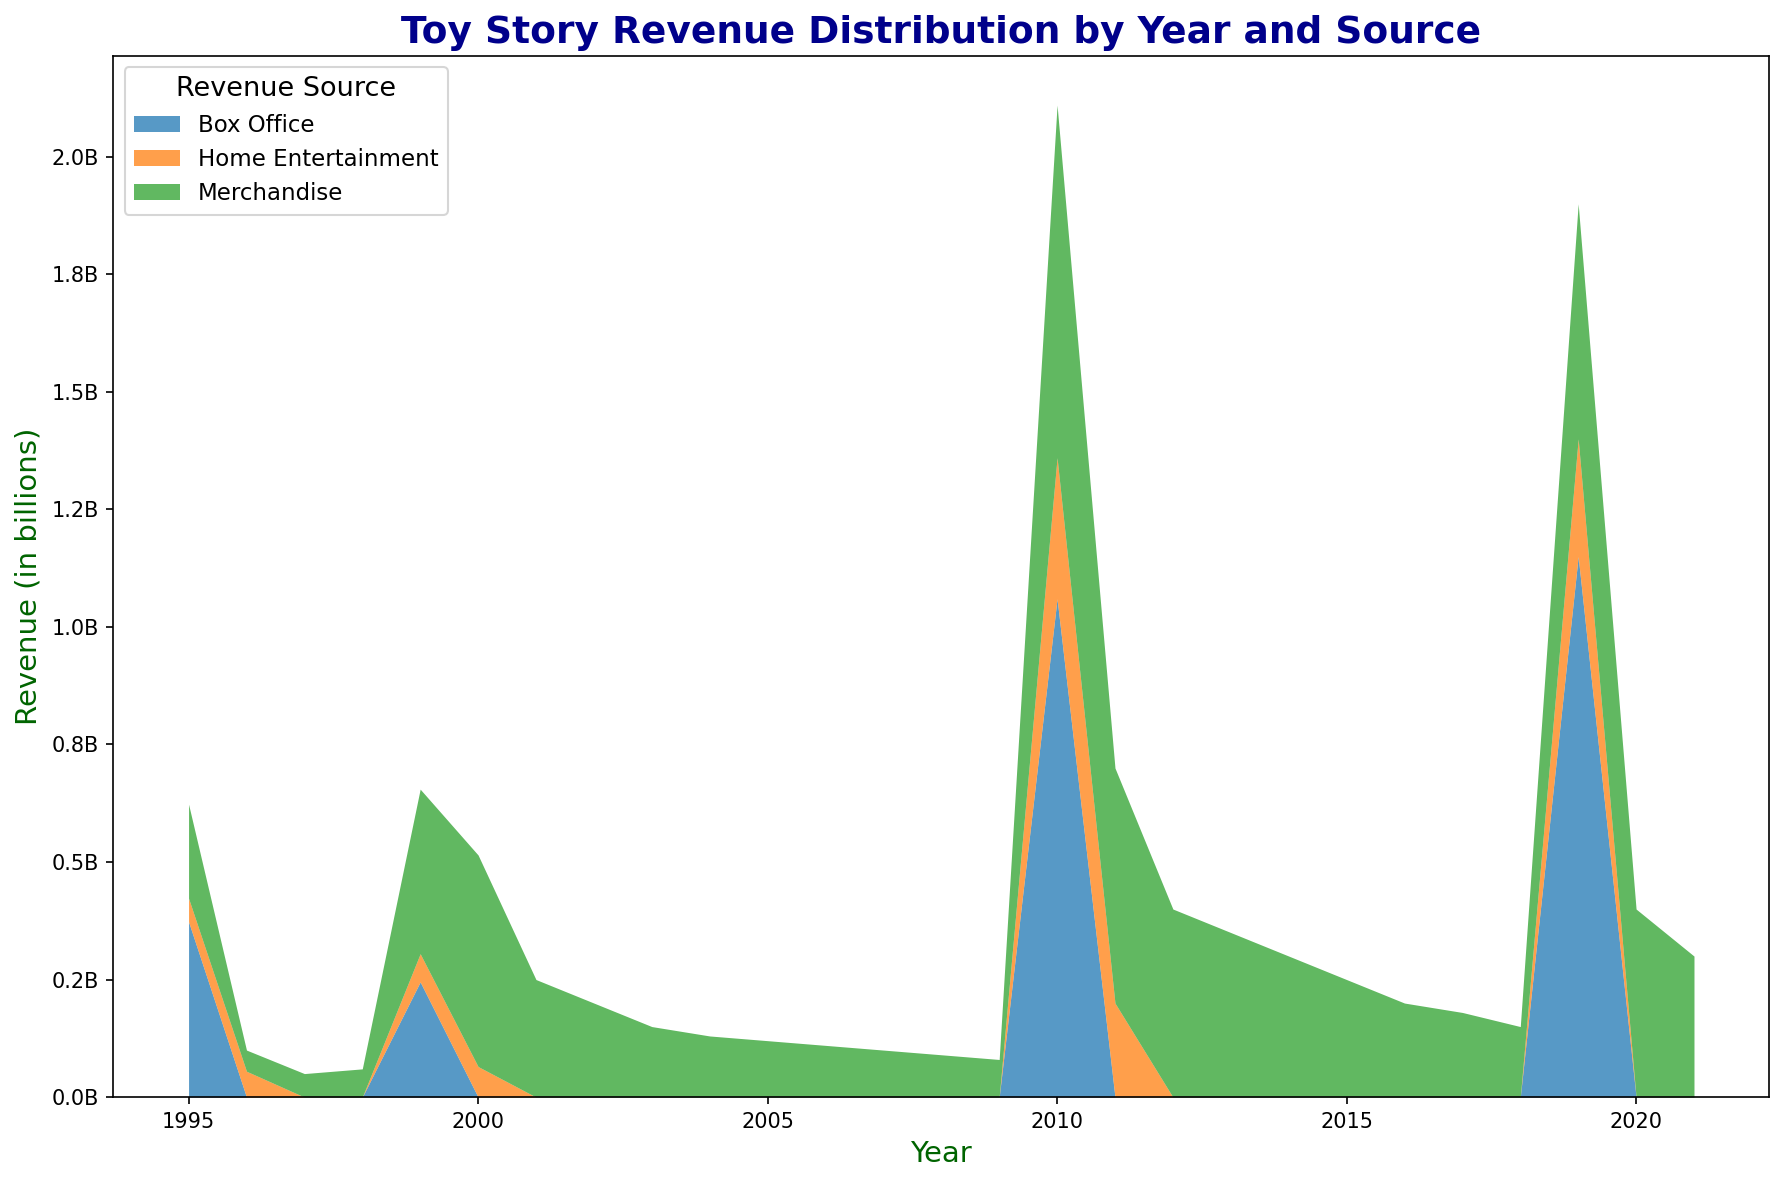What years did Toy Story movies generate box office revenue? By observing the x-axis for box office revenue areas, the years with noticeable contribution are 1995, 1999, 2010, and 2019. These are depicted by the distinct portions in each year for box office earnings.
Answer: 1995, 1999, 2010, 2019 Which source of revenue consistently generated the most income throughout the years? By assessing the stacked area chart, it's clear that merchandise revenue consistently occupies the largest area across most years. This indicates that merchandise has been the most substantial source of revenue over time.
Answer: Merchandise In which year did merchandise revenue peak? We can determine that merchandise revenue peaked by identifying the year with the highest area width for merchandise. The largest segment occurs in 2010, indicating the peak for merchandise revenue.
Answer: 2010 Compare the box office revenue between 2010 and 2019. Which year had higher revenue and by how much? Examining the areas corresponding to box office revenue for both 2010 and 2019 shows that 2019 had a higher revenue. Calculating the difference, we see 2019 had $1,150,000,000 whereas 2010 had $1,060,000,000. The difference is $90,000,000.
Answer: 2019 by $90,000,000 What is the total revenue generated in 2010 from all sources? Adding the revenues from box office ($1,060,000,000), merchandise ($750,000,000), and home entertainment ($300,000,000) for 2010 gives the total revenue: $1,060,000,000 + $750,000,000 + $300,000,000 = $2,110,000,000.
Answer: $2,110,000,000 Which source had the most variable revenue over the years, and how can you tell? By looking at the vertical height variations for each source, box office and home entertainment show significant fluctuations, but merchandise exhibits the largest changes over multiple years, indicating it is the most variable.
Answer: Merchandise How does the 2011 home entertainment revenue compare to that in 2010? Observing the heights of the home entertainment areas for 2010 and 2011, 2010 shows $300,000,000 whereas 2011 shows $200,000,000. Therefore, 2010 generated $100,000,000 more from home entertainment than 2011.
Answer: 2010 had $100,000,000 more What is the average merchandise revenue from 2017 to 2021? Summing the merchandise revenue values from 2017 to 2021 ($180,000,000 + $150,000,000 + $500,000,000 + $400,000,000 + $300,000,000) gives $1,530,000,000. Dividing by 5 (number of years) gives the average: $1,530,000,000 / 5 = $306,000,000.
Answer: $306,000,000 In which year did home entertainment revenue first exceed $200,000,000? Reviewing the home entertainment areas, the first instance where it exceeds $200,000,000 is in 2010, where it reached $300,000,000.
Answer: 2010 Compare the combined revenues of merchandise in 1995 and 1996 against 1999. Which is greater? Summing merchandise revenues for 1995 ($200,000,000) and 1996 ($45,000,000) equals $245,000,000, while 1999's merchandise revenue is $350,000,000. 1999's merchandise revenue is greater by $105,000,000.
Answer: 1999 is greater by $105,000,000 